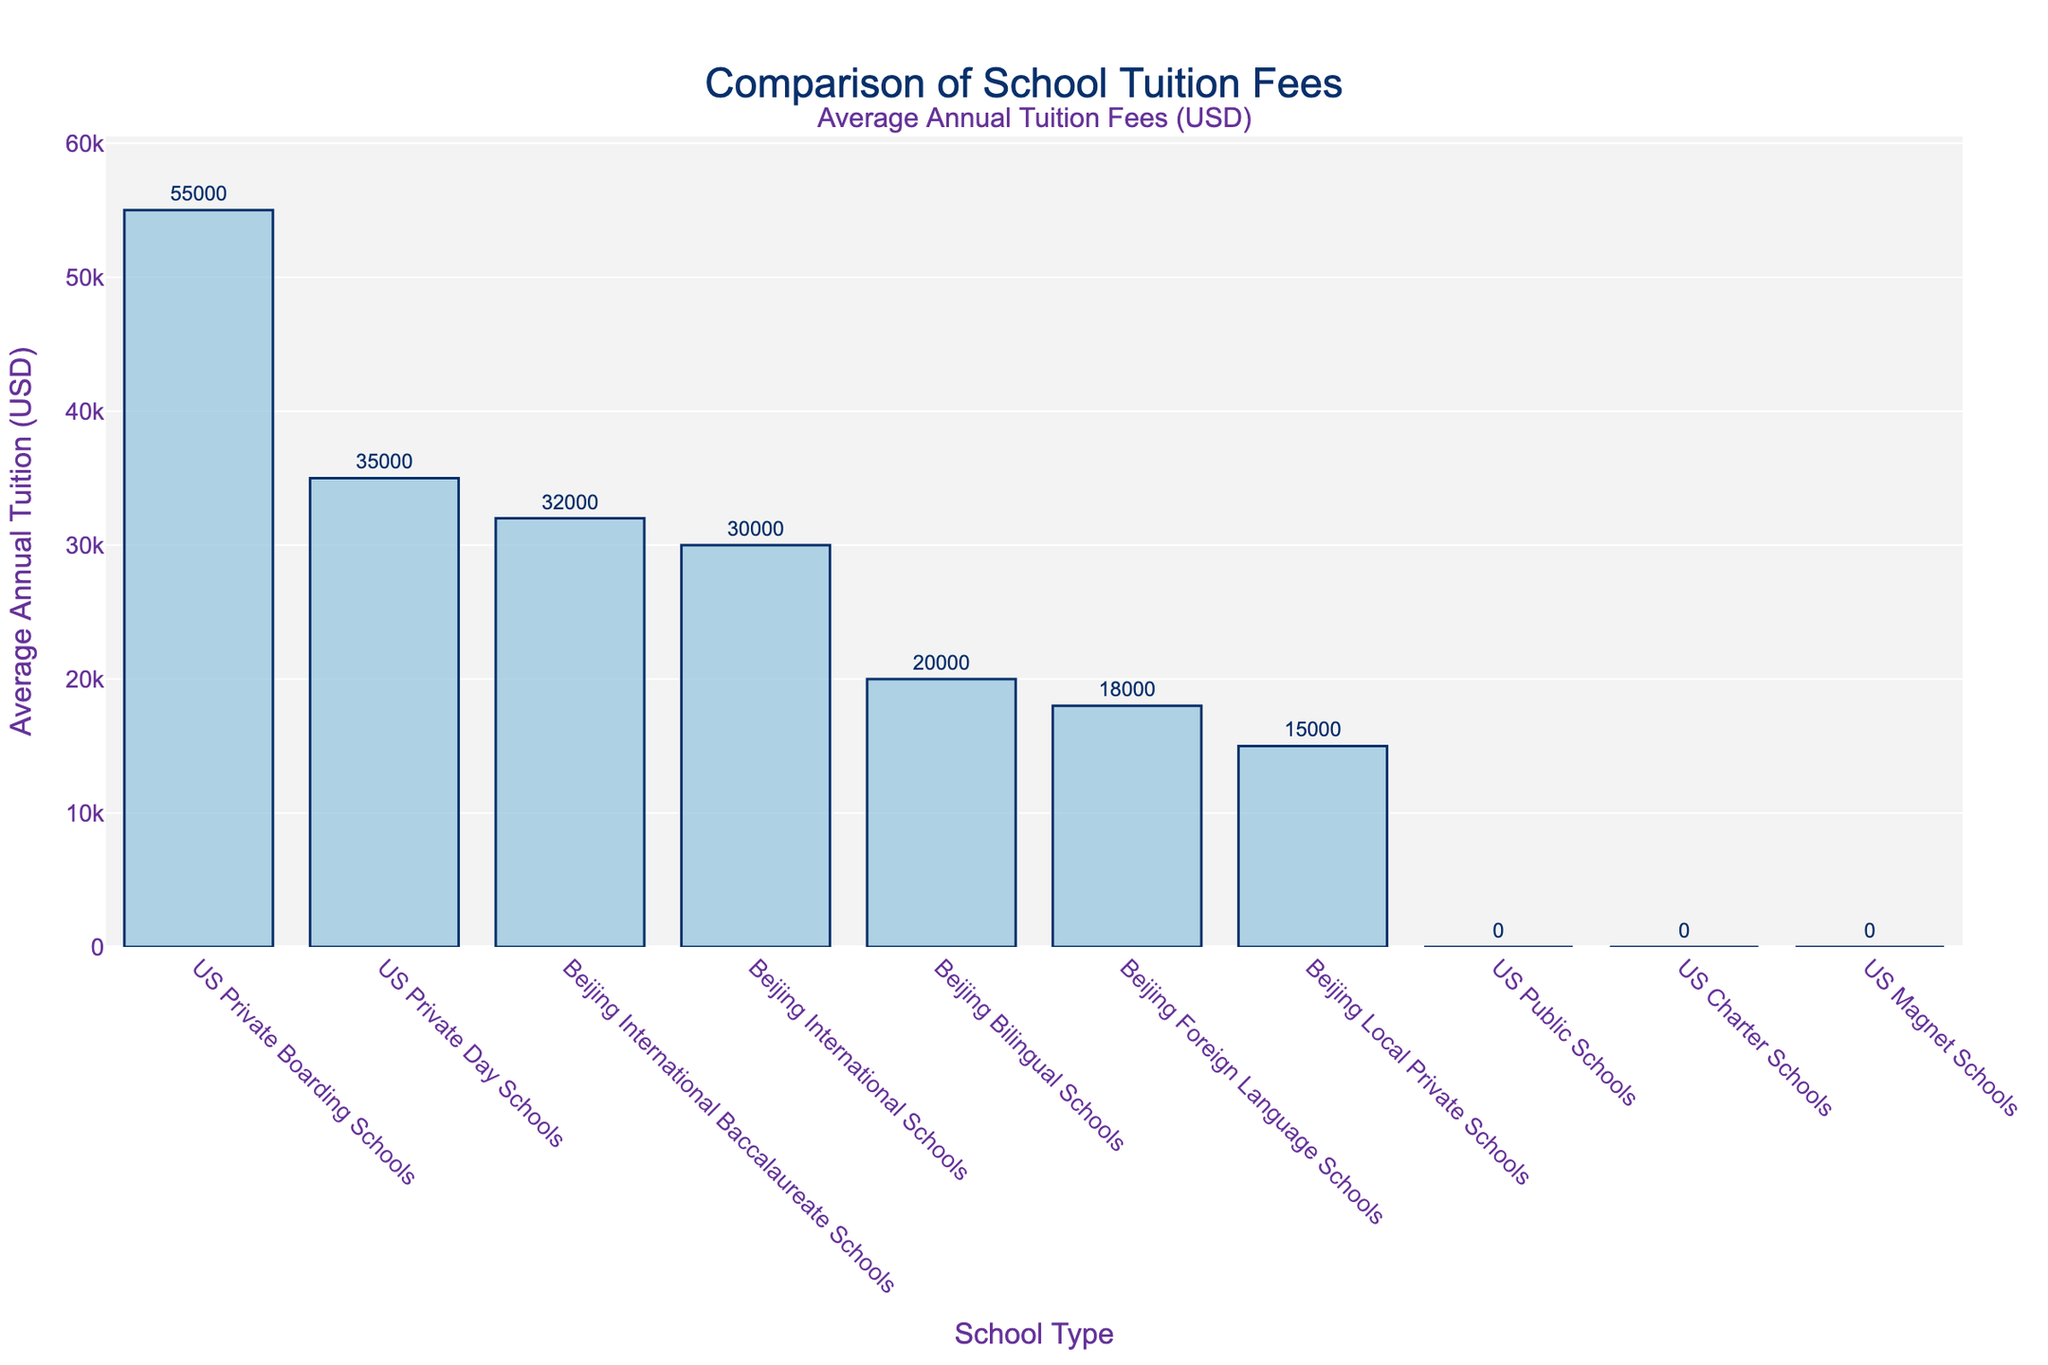Which school type has the highest average tuition fee? The bar corresponding to US Private Boarding Schools is the tallest in the figure, indicating that it has the highest average tuition fee.
Answer: US Private Boarding Schools How much more expensive are US Private Boarding Schools compared to Beijing International Schools? The average tuition for US Private Boarding Schools is $55,000, and for Beijing International Schools, it is $30,000. The difference is $55,000 - $30,000 = $25,000.
Answer: $25,000 What is the median average tuition fee among the school types listed? To find the median, we first list the average tuitions in ascending order: $0, $0, $0, $15,000, $18,000, $20,000, $30,000, $32,000, $35,000, $55,000. Since there are 10 data points, the median will be the average of the 5th and 6th values: ($18,000 + $20,000) / 2 = $19,000.
Answer: $19,000 Which school types have the same average tuition fee? From the figure, US Public Schools, US Charter Schools, and US Magnet Schools all have an average tuition fee of $0, as indicated by the heights of their respective bars.
Answer: US Public Schools, US Charter Schools, US Magnet Schools What is the total average tuition fee for all the Beijing school types? Adding up the average tuitions for all Beijing schools: $30,000 (International) + $20,000 (Bilingual) + $15,000 (Local Private) + $18,000 (Foreign Language) + $32,000 (International Baccalaureate) = $115,000.
Answer: $115,000 How does the average tuition fee of Beijing Local Private Schools compare to that of Beijing Foreign Language Schools? The average tuition fee for Beijing Local Private Schools is $15,000, while for Beijing Foreign Language Schools, it is $18,000. Comparatively, Beijing Local Private Schools are $3,000 less expensive.
Answer: $3,000 less expensive What is the difference in average tuition between the most expensive and least expensive school types? The most expensive is US Private Boarding Schools at $55,000 and the least expensive are US Public Schools, US Charter Schools, and US Magnet Schools at $0. The difference is $55,000 - $0 = $55,000.
Answer: $55,000 Which school type among all listed has a higher tuition fee than $30,000 but less than $55,000? The school types that fit this criteria from the figure are Beijing International Schools ($30,000 < $32,000 < $55,000) and US Private Day Schools ($30,000 < $35,000 < $55,000).
Answer: Beijing International Schools, US Private Day Schools 